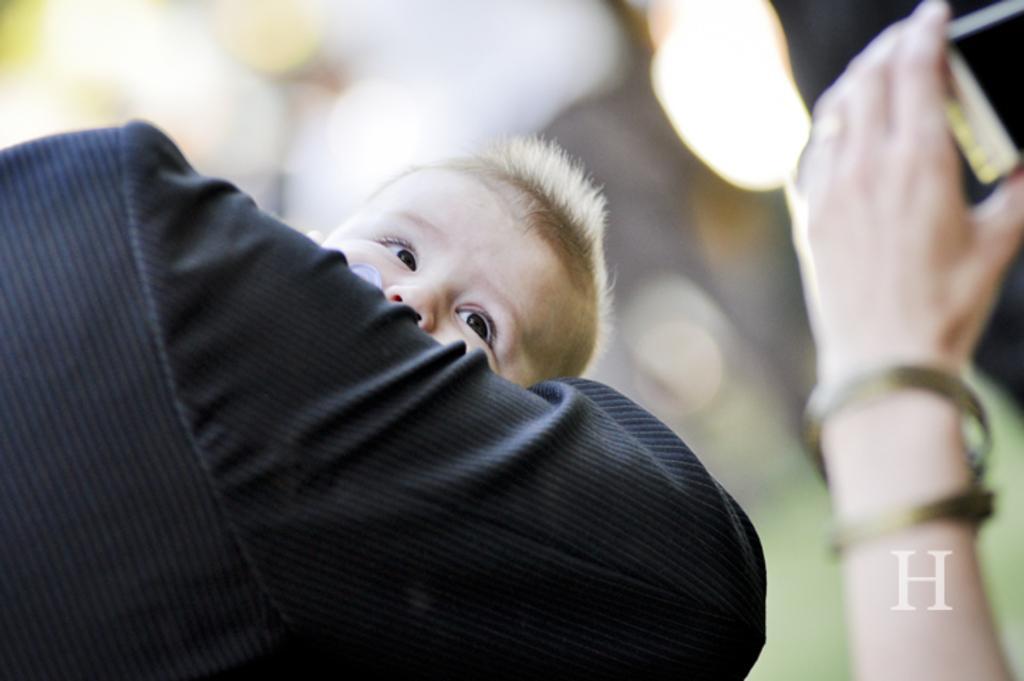Please provide a concise description of this image. In this image we can see a person wearing blazer is carrying a child in their hands. This part of the image is blurred, where we can see a person's hand holding a mobile phone. Here we can see the letter H. 